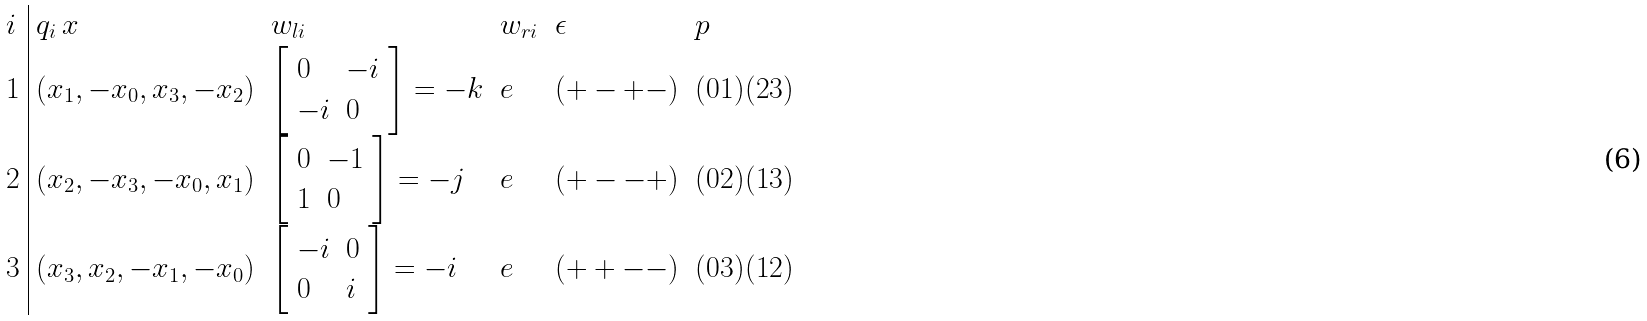Convert formula to latex. <formula><loc_0><loc_0><loc_500><loc_500>\begin{array} { l | l l l l l } i & q _ { i } \, x & w _ { l i } & w _ { r i } & \epsilon & p \\ 1 & ( x _ { 1 } , - x _ { 0 } , x _ { 3 } , - x _ { 2 } ) & \left [ \begin{array} { l l } 0 & - i \\ - i & 0 \\ \end{array} \right ] = - { k } & e & ( + - + - ) & ( 0 1 ) ( 2 3 ) \\ 2 & ( x _ { 2 } , - x _ { 3 } , - x _ { 0 } , x _ { 1 } ) & \left [ \begin{array} { l l } 0 & - 1 \\ 1 & 0 \\ \end{array} \right ] = - { j } & e & ( + - - + ) & ( 0 2 ) ( 1 3 ) \\ 3 & ( x _ { 3 } , x _ { 2 } , - x _ { 1 } , - x _ { 0 } ) & \left [ \begin{array} { l l } - i & 0 \\ 0 & i \\ \end{array} \right ] = - { i } & e & ( + + - - ) & ( 0 3 ) ( 1 2 ) \\ \end{array}</formula> 